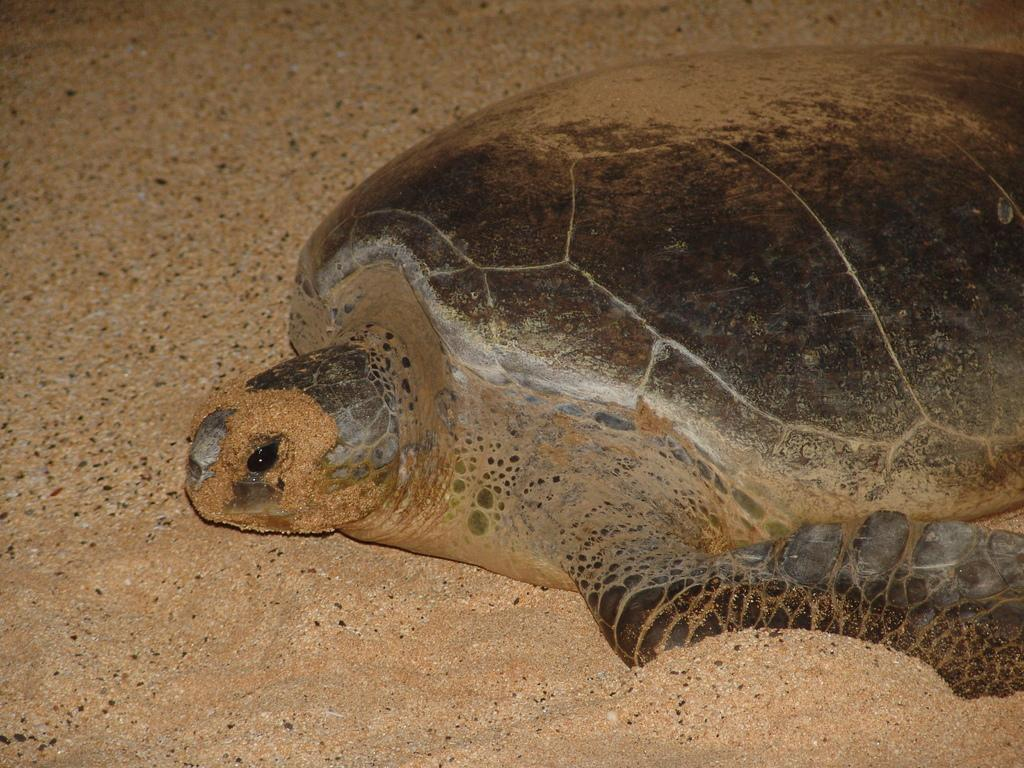What animal is present in the image? There is a turtle in the image. What colors can be seen on the turtle? The turtle is in brown and black colors. What type of terrain is visible at the bottom of the image? There are rocks visible at the bottom of the image. Where might this image have been taken? The image might have been taken in a zoo. What hobbies does the cow in the image enjoy? There is no cow present in the image; it features a turtle. What level of education does the turtle in the image have? The turtle's education level cannot be determined from the image. 